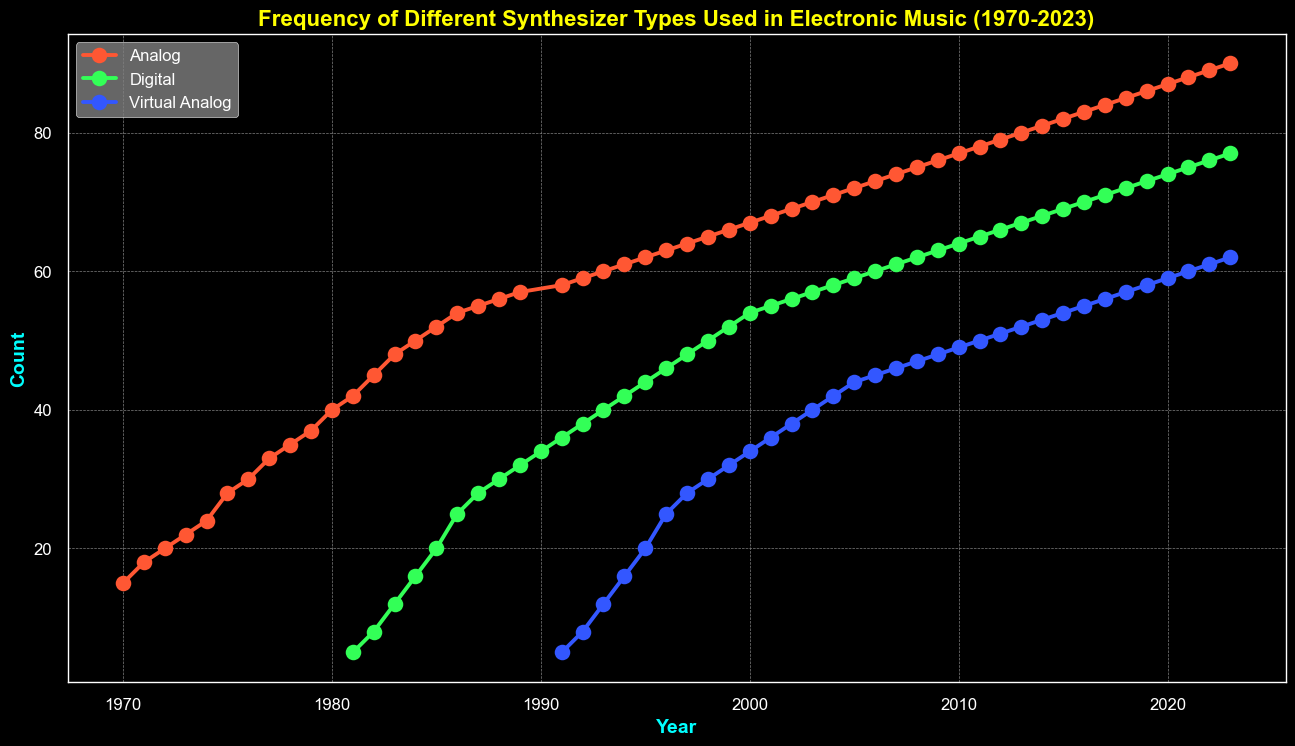What synth type shows the highest frequency in 1973? By looking at 1973 in the plot, the analog synth type has the highest value since only analog synths existed at that point.
Answer: Analog When did digital synthesizers first appear, and what was their count? Digital synthesizers first appear in the year 1981, as shown by the plot with a small spike starting in 1981 at count 5.
Answer: 1981, count 5 Compare the frequency of Analog synthesizers between 1975 and 1985. How has it changed? In 1975, the frequency of Analog synthesizers was 28. By 1985, it increased to 52. The change is calculated as 52 - 28.
Answer: Increased by 24 Which synthesizer type shows the most consistent growth over the years? By observing the slope and smoothness of the lines over the years, Analog synths show the most consistent, steady increase without significant drops.
Answer: Analog How does the frequency of Virtual Analog synthesizers in 2015 compare to that in 2020? In 2015, the frequency is 54, and in 2020 it is 59. The frequency increased by looking at the higher value in 2020.
Answer: Increased What is the frequency difference between Digital and Analog synthesizers in the year 2000? In 2000, the frequency of Digital synthesizers is 54 and that of Analog is 67. Calculate the absolute difference: 67 - 54.
Answer: 13 What year did Virtual Analog synthesizers reach a frequency of 40? Looking at the plot, the Virtual Analog synthesizers reach a frequency of 40 in the year 2003.
Answer: 2003 What trend do you observe for Digital synthesizers from 1981 to 2023? Digital synthesizers show an initial consistent increase from 1981 to 2023 without major fluctuations, continuously growing each year.
Answer: Consistent growth When did the frequency of Analog synthesizers peak, and what was the count? The frequency of Analog synthesizers peaks in 2023 as indicated by the highest point of the line representing Analog, with a count of 90.
Answer: 2023, 90 Which year saw the introduction of Virtual Analog synthesizers, and what was their initial count? Virtual Analog synthesizers appear first in the year 1991, with an initial count of 5 as shown by the start of the line for Virtual Analog.
Answer: 1991, 5 